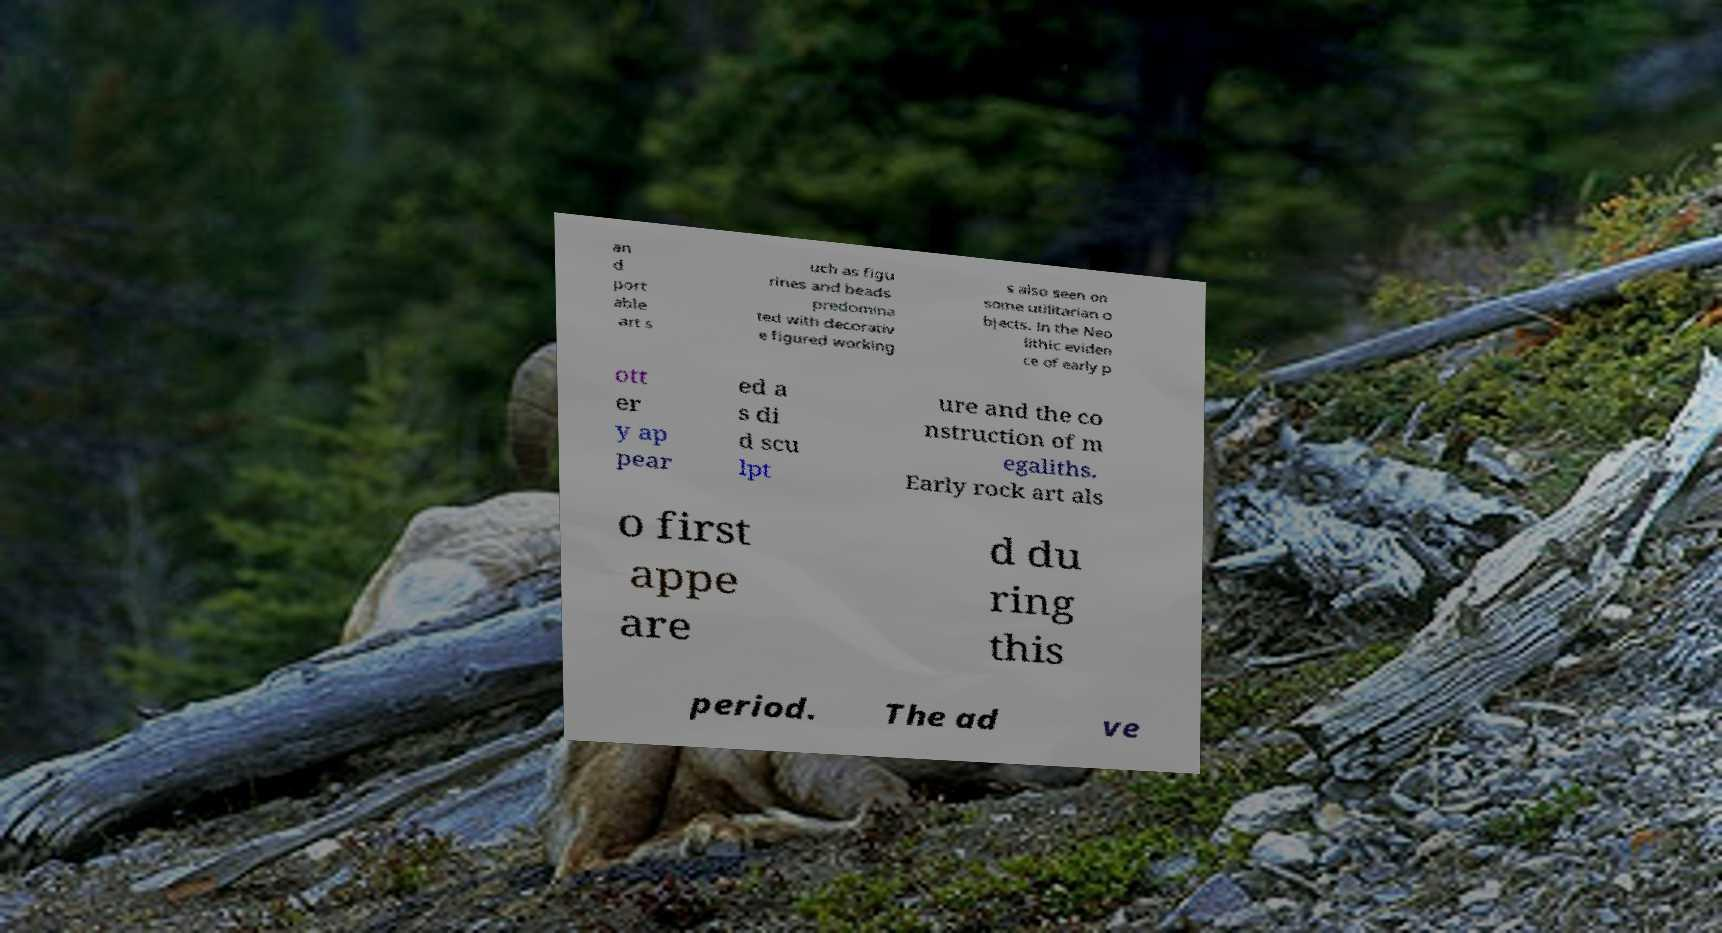For documentation purposes, I need the text within this image transcribed. Could you provide that? an d port able art s uch as figu rines and beads predomina ted with decorativ e figured working s also seen on some utilitarian o bjects. In the Neo lithic eviden ce of early p ott er y ap pear ed a s di d scu lpt ure and the co nstruction of m egaliths. Early rock art als o first appe are d du ring this period. The ad ve 